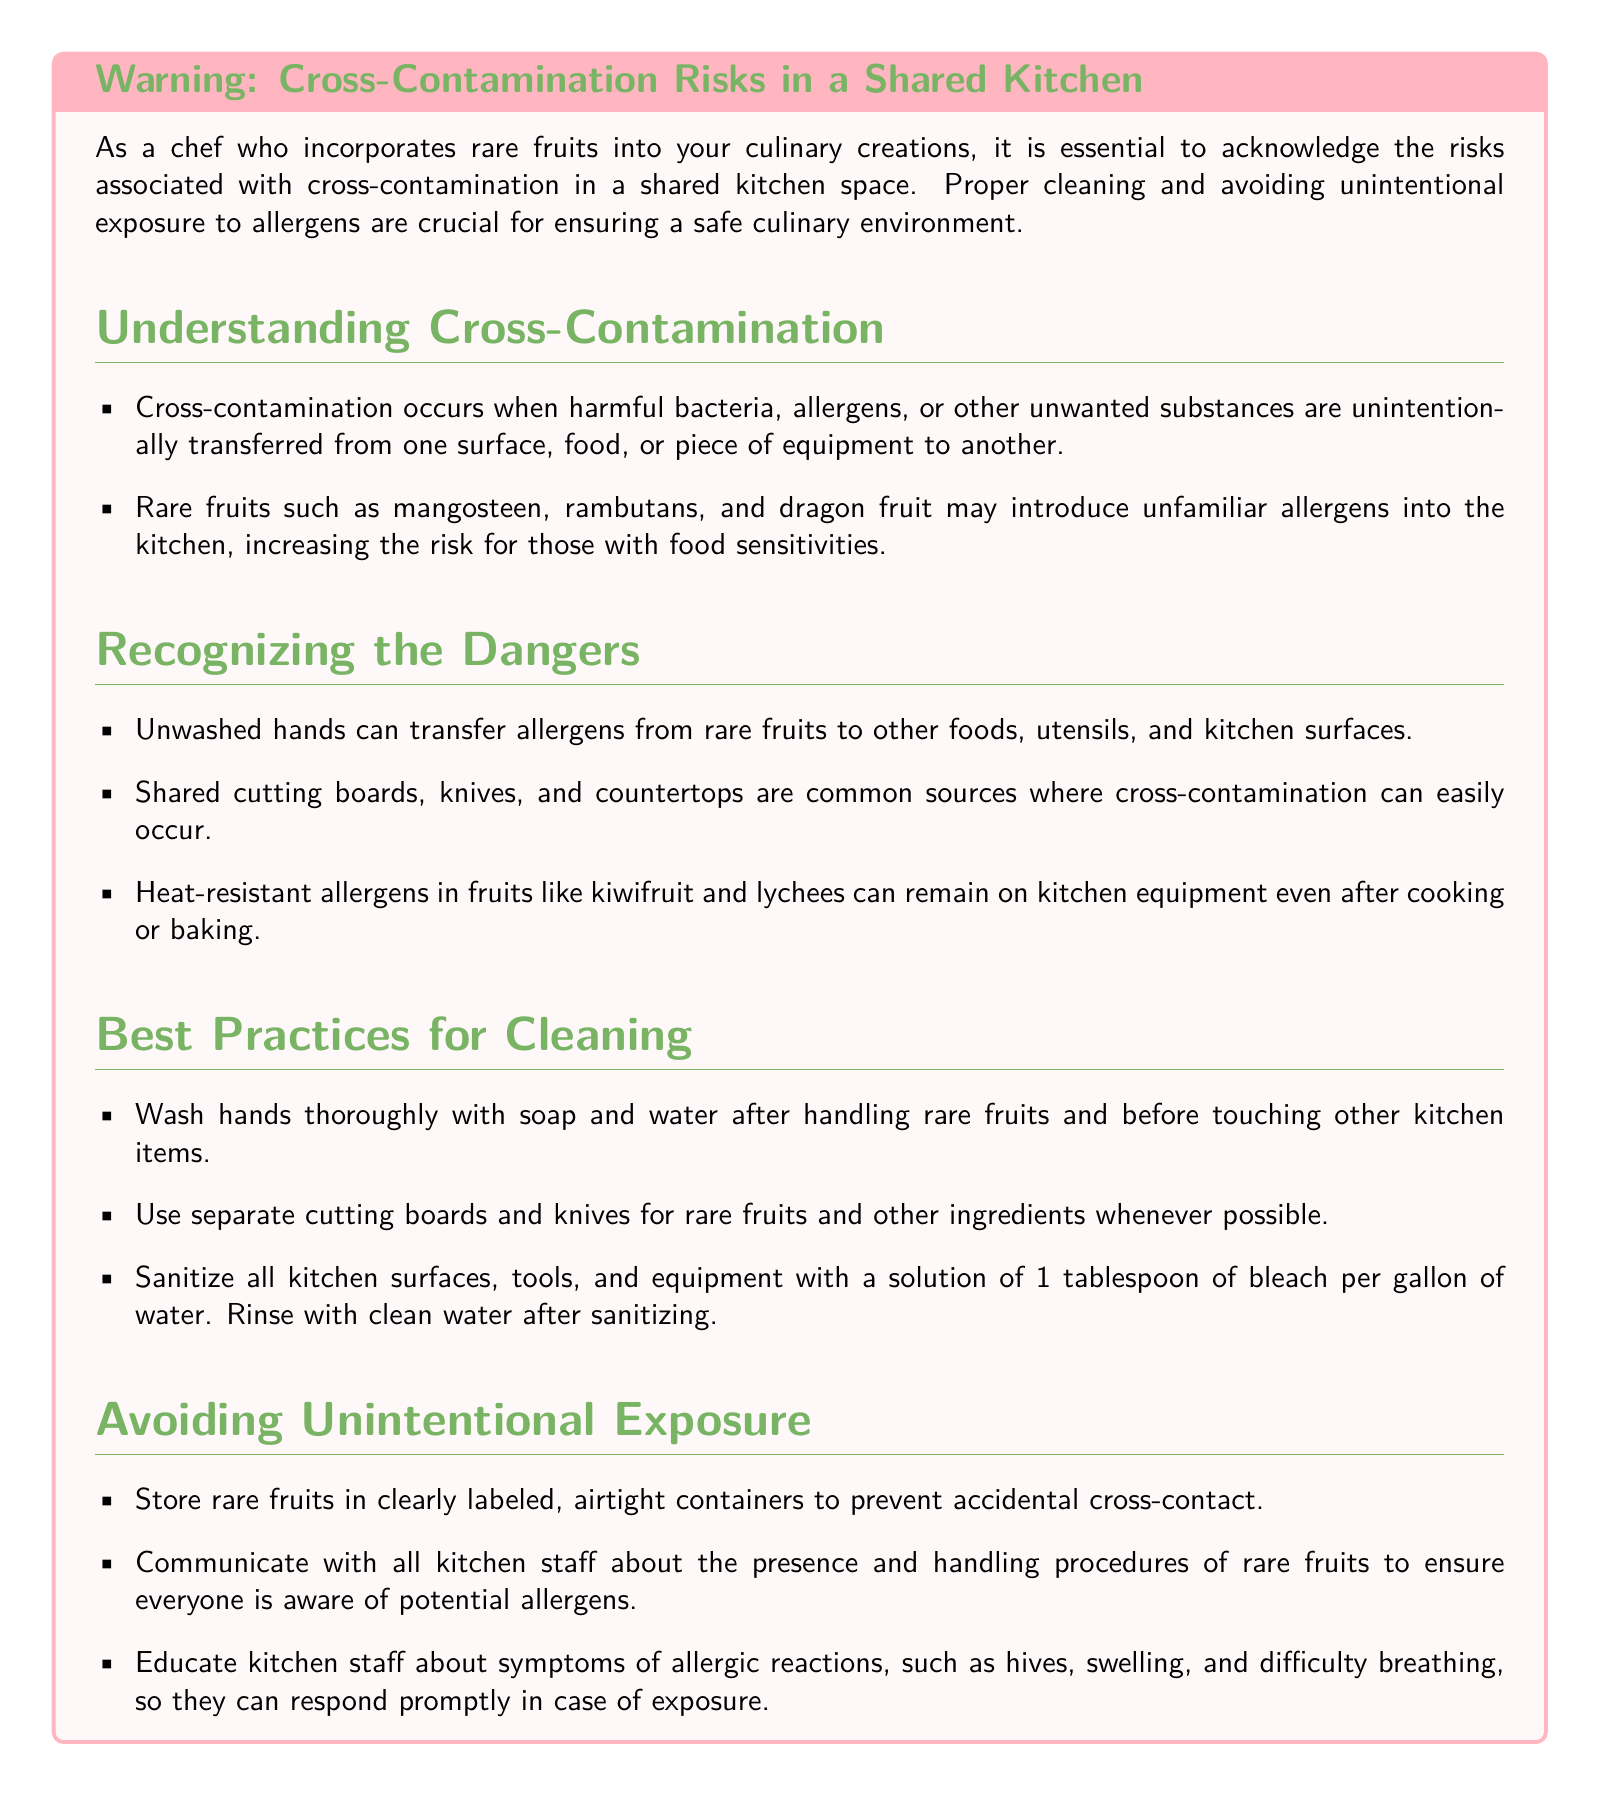What is cross-contamination? Cross-contamination is defined in the document as the unintentional transfer of harmful bacteria, allergens, or other unwanted substances from one surface, food, or piece of equipment to another.
Answer: Unintentional transfer What should be used to sanitize kitchen surfaces? The document specifies using a solution of 1 tablespoon of bleach per gallon of water to sanitize kitchen surfaces.
Answer: Bleach solution Name a rare fruit that may introduce unfamiliar allergens. The document lists mangosteen, rambutans, and dragon fruit as examples of rare fruits that may introduce unfamiliar allergens.
Answer: Mangosteen What is the first step in best practices for cleaning? The document emphasizes that the first step is to wash hands thoroughly with soap and water after handling rare fruits.
Answer: Wash hands Why is it important to store rare fruits in airtight containers? The document mentions that storing rare fruits in airtight containers prevents accidental cross-contact with other foods.
Answer: Prevent accidental cross-contact What symptoms should kitchen staff be educated about? The document highlights that kitchen staff should be educated about symptoms of allergic reactions, including hives, swelling, and difficulty breathing.
Answer: Hives, swelling, difficulty breathing What is a common source of cross-contamination in the kitchen? According to the document, shared cutting boards, knives, and countertops are common sources of cross-contamination.
Answer: Shared cutting boards How can kitchen staff ensure awareness of potential allergens? The document advises that communicating with all kitchen staff about the presence and handling procedures of rare fruits ensures awareness of potential allergens.
Answer: Communicating with staff 